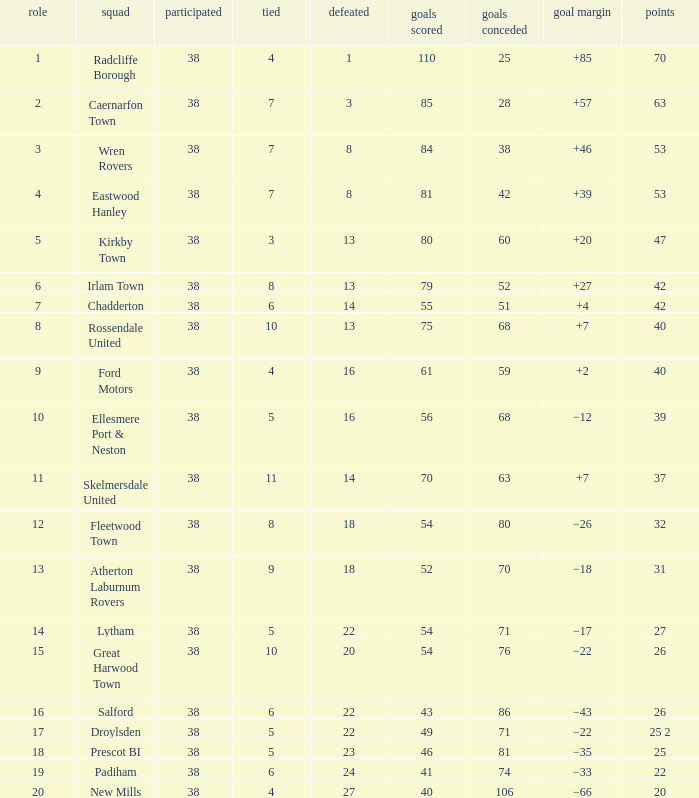Which Played has a Drawn of 4, and a Position of 9, and Goals Against larger than 59? None. 